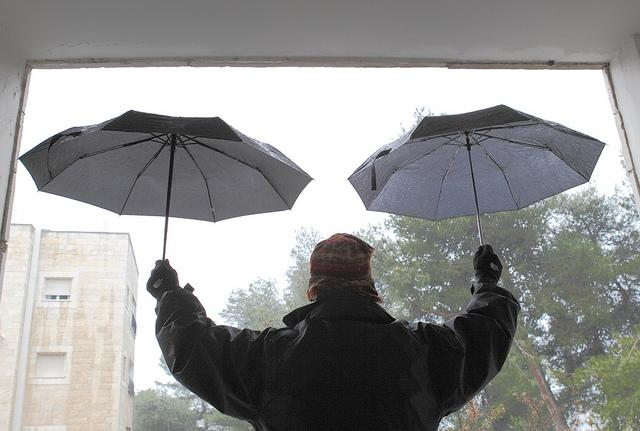What weather is being encountered here? Please explain your reasoning. rain. A person is holding up two umbrellas in an overcast area. the skies are hazy. 